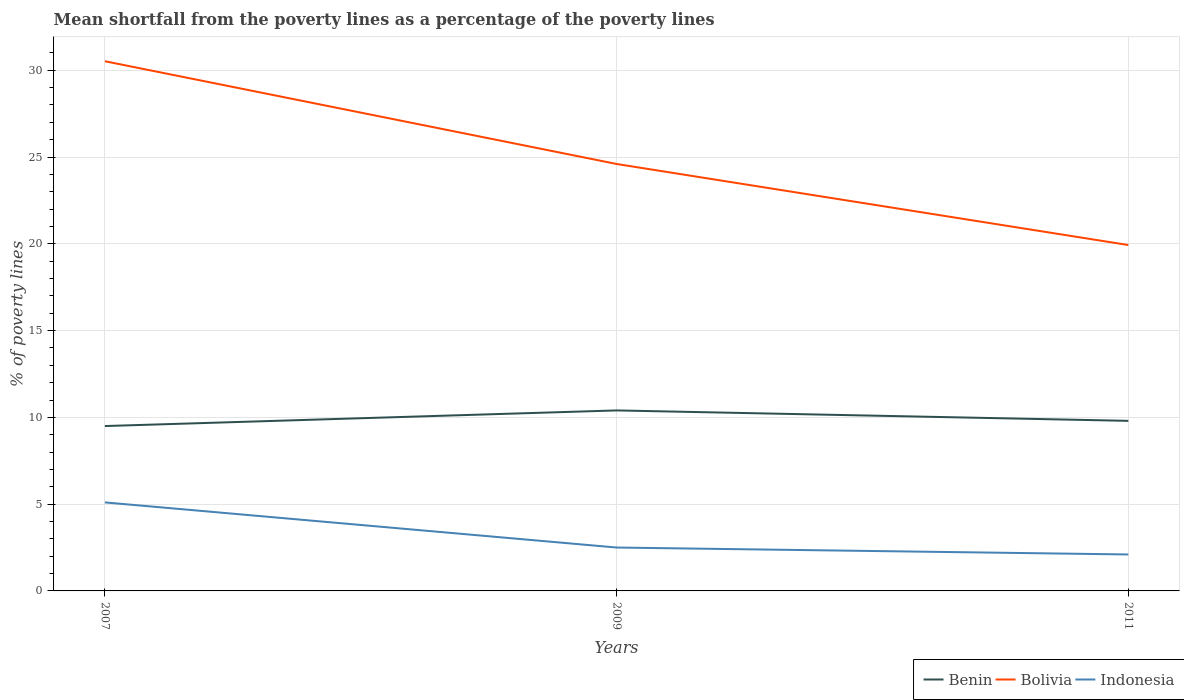Does the line corresponding to Benin intersect with the line corresponding to Bolivia?
Ensure brevity in your answer.  No. In which year was the mean shortfall from the poverty lines as a percentage of the poverty lines in Bolivia maximum?
Provide a succinct answer. 2011. What is the total mean shortfall from the poverty lines as a percentage of the poverty lines in Bolivia in the graph?
Provide a short and direct response. 10.59. What is the difference between the highest and the second highest mean shortfall from the poverty lines as a percentage of the poverty lines in Benin?
Offer a very short reply. 0.9. What is the difference between the highest and the lowest mean shortfall from the poverty lines as a percentage of the poverty lines in Bolivia?
Give a very brief answer. 1. Is the mean shortfall from the poverty lines as a percentage of the poverty lines in Bolivia strictly greater than the mean shortfall from the poverty lines as a percentage of the poverty lines in Benin over the years?
Offer a very short reply. No. What is the difference between two consecutive major ticks on the Y-axis?
Offer a very short reply. 5. How are the legend labels stacked?
Your answer should be very brief. Horizontal. What is the title of the graph?
Provide a short and direct response. Mean shortfall from the poverty lines as a percentage of the poverty lines. What is the label or title of the Y-axis?
Your response must be concise. % of poverty lines. What is the % of poverty lines in Bolivia in 2007?
Ensure brevity in your answer.  30.52. What is the % of poverty lines in Indonesia in 2007?
Your answer should be compact. 5.1. What is the % of poverty lines in Bolivia in 2009?
Give a very brief answer. 24.6. What is the % of poverty lines in Benin in 2011?
Ensure brevity in your answer.  9.8. What is the % of poverty lines of Bolivia in 2011?
Provide a succinct answer. 19.93. Across all years, what is the maximum % of poverty lines in Bolivia?
Your response must be concise. 30.52. Across all years, what is the maximum % of poverty lines of Indonesia?
Provide a short and direct response. 5.1. Across all years, what is the minimum % of poverty lines in Bolivia?
Make the answer very short. 19.93. What is the total % of poverty lines of Benin in the graph?
Provide a short and direct response. 29.7. What is the total % of poverty lines in Bolivia in the graph?
Your response must be concise. 75.05. What is the total % of poverty lines of Indonesia in the graph?
Keep it short and to the point. 9.7. What is the difference between the % of poverty lines in Benin in 2007 and that in 2009?
Ensure brevity in your answer.  -0.9. What is the difference between the % of poverty lines in Bolivia in 2007 and that in 2009?
Your answer should be compact. 5.92. What is the difference between the % of poverty lines of Benin in 2007 and that in 2011?
Your answer should be very brief. -0.3. What is the difference between the % of poverty lines in Bolivia in 2007 and that in 2011?
Your answer should be very brief. 10.59. What is the difference between the % of poverty lines of Indonesia in 2007 and that in 2011?
Provide a short and direct response. 3. What is the difference between the % of poverty lines of Benin in 2009 and that in 2011?
Your answer should be very brief. 0.6. What is the difference between the % of poverty lines of Bolivia in 2009 and that in 2011?
Provide a short and direct response. 4.67. What is the difference between the % of poverty lines in Benin in 2007 and the % of poverty lines in Bolivia in 2009?
Your answer should be compact. -15.1. What is the difference between the % of poverty lines in Benin in 2007 and the % of poverty lines in Indonesia in 2009?
Keep it short and to the point. 7. What is the difference between the % of poverty lines in Bolivia in 2007 and the % of poverty lines in Indonesia in 2009?
Offer a terse response. 28.02. What is the difference between the % of poverty lines in Benin in 2007 and the % of poverty lines in Bolivia in 2011?
Provide a short and direct response. -10.43. What is the difference between the % of poverty lines in Benin in 2007 and the % of poverty lines in Indonesia in 2011?
Keep it short and to the point. 7.4. What is the difference between the % of poverty lines in Bolivia in 2007 and the % of poverty lines in Indonesia in 2011?
Make the answer very short. 28.42. What is the difference between the % of poverty lines in Benin in 2009 and the % of poverty lines in Bolivia in 2011?
Offer a very short reply. -9.53. What is the difference between the % of poverty lines in Benin in 2009 and the % of poverty lines in Indonesia in 2011?
Your response must be concise. 8.3. What is the average % of poverty lines of Benin per year?
Give a very brief answer. 9.9. What is the average % of poverty lines in Bolivia per year?
Make the answer very short. 25.02. What is the average % of poverty lines of Indonesia per year?
Ensure brevity in your answer.  3.23. In the year 2007, what is the difference between the % of poverty lines in Benin and % of poverty lines in Bolivia?
Make the answer very short. -21.02. In the year 2007, what is the difference between the % of poverty lines in Bolivia and % of poverty lines in Indonesia?
Give a very brief answer. 25.42. In the year 2009, what is the difference between the % of poverty lines of Benin and % of poverty lines of Bolivia?
Ensure brevity in your answer.  -14.2. In the year 2009, what is the difference between the % of poverty lines in Benin and % of poverty lines in Indonesia?
Your response must be concise. 7.9. In the year 2009, what is the difference between the % of poverty lines in Bolivia and % of poverty lines in Indonesia?
Your answer should be compact. 22.1. In the year 2011, what is the difference between the % of poverty lines in Benin and % of poverty lines in Bolivia?
Ensure brevity in your answer.  -10.13. In the year 2011, what is the difference between the % of poverty lines in Benin and % of poverty lines in Indonesia?
Offer a terse response. 7.7. In the year 2011, what is the difference between the % of poverty lines in Bolivia and % of poverty lines in Indonesia?
Give a very brief answer. 17.83. What is the ratio of the % of poverty lines in Benin in 2007 to that in 2009?
Offer a terse response. 0.91. What is the ratio of the % of poverty lines of Bolivia in 2007 to that in 2009?
Keep it short and to the point. 1.24. What is the ratio of the % of poverty lines of Indonesia in 2007 to that in 2009?
Your answer should be compact. 2.04. What is the ratio of the % of poverty lines of Benin in 2007 to that in 2011?
Your answer should be compact. 0.97. What is the ratio of the % of poverty lines in Bolivia in 2007 to that in 2011?
Keep it short and to the point. 1.53. What is the ratio of the % of poverty lines of Indonesia in 2007 to that in 2011?
Your answer should be very brief. 2.43. What is the ratio of the % of poverty lines of Benin in 2009 to that in 2011?
Your answer should be very brief. 1.06. What is the ratio of the % of poverty lines in Bolivia in 2009 to that in 2011?
Keep it short and to the point. 1.23. What is the ratio of the % of poverty lines in Indonesia in 2009 to that in 2011?
Make the answer very short. 1.19. What is the difference between the highest and the second highest % of poverty lines of Bolivia?
Give a very brief answer. 5.92. What is the difference between the highest and the lowest % of poverty lines of Benin?
Provide a short and direct response. 0.9. What is the difference between the highest and the lowest % of poverty lines of Bolivia?
Your answer should be compact. 10.59. What is the difference between the highest and the lowest % of poverty lines of Indonesia?
Provide a succinct answer. 3. 